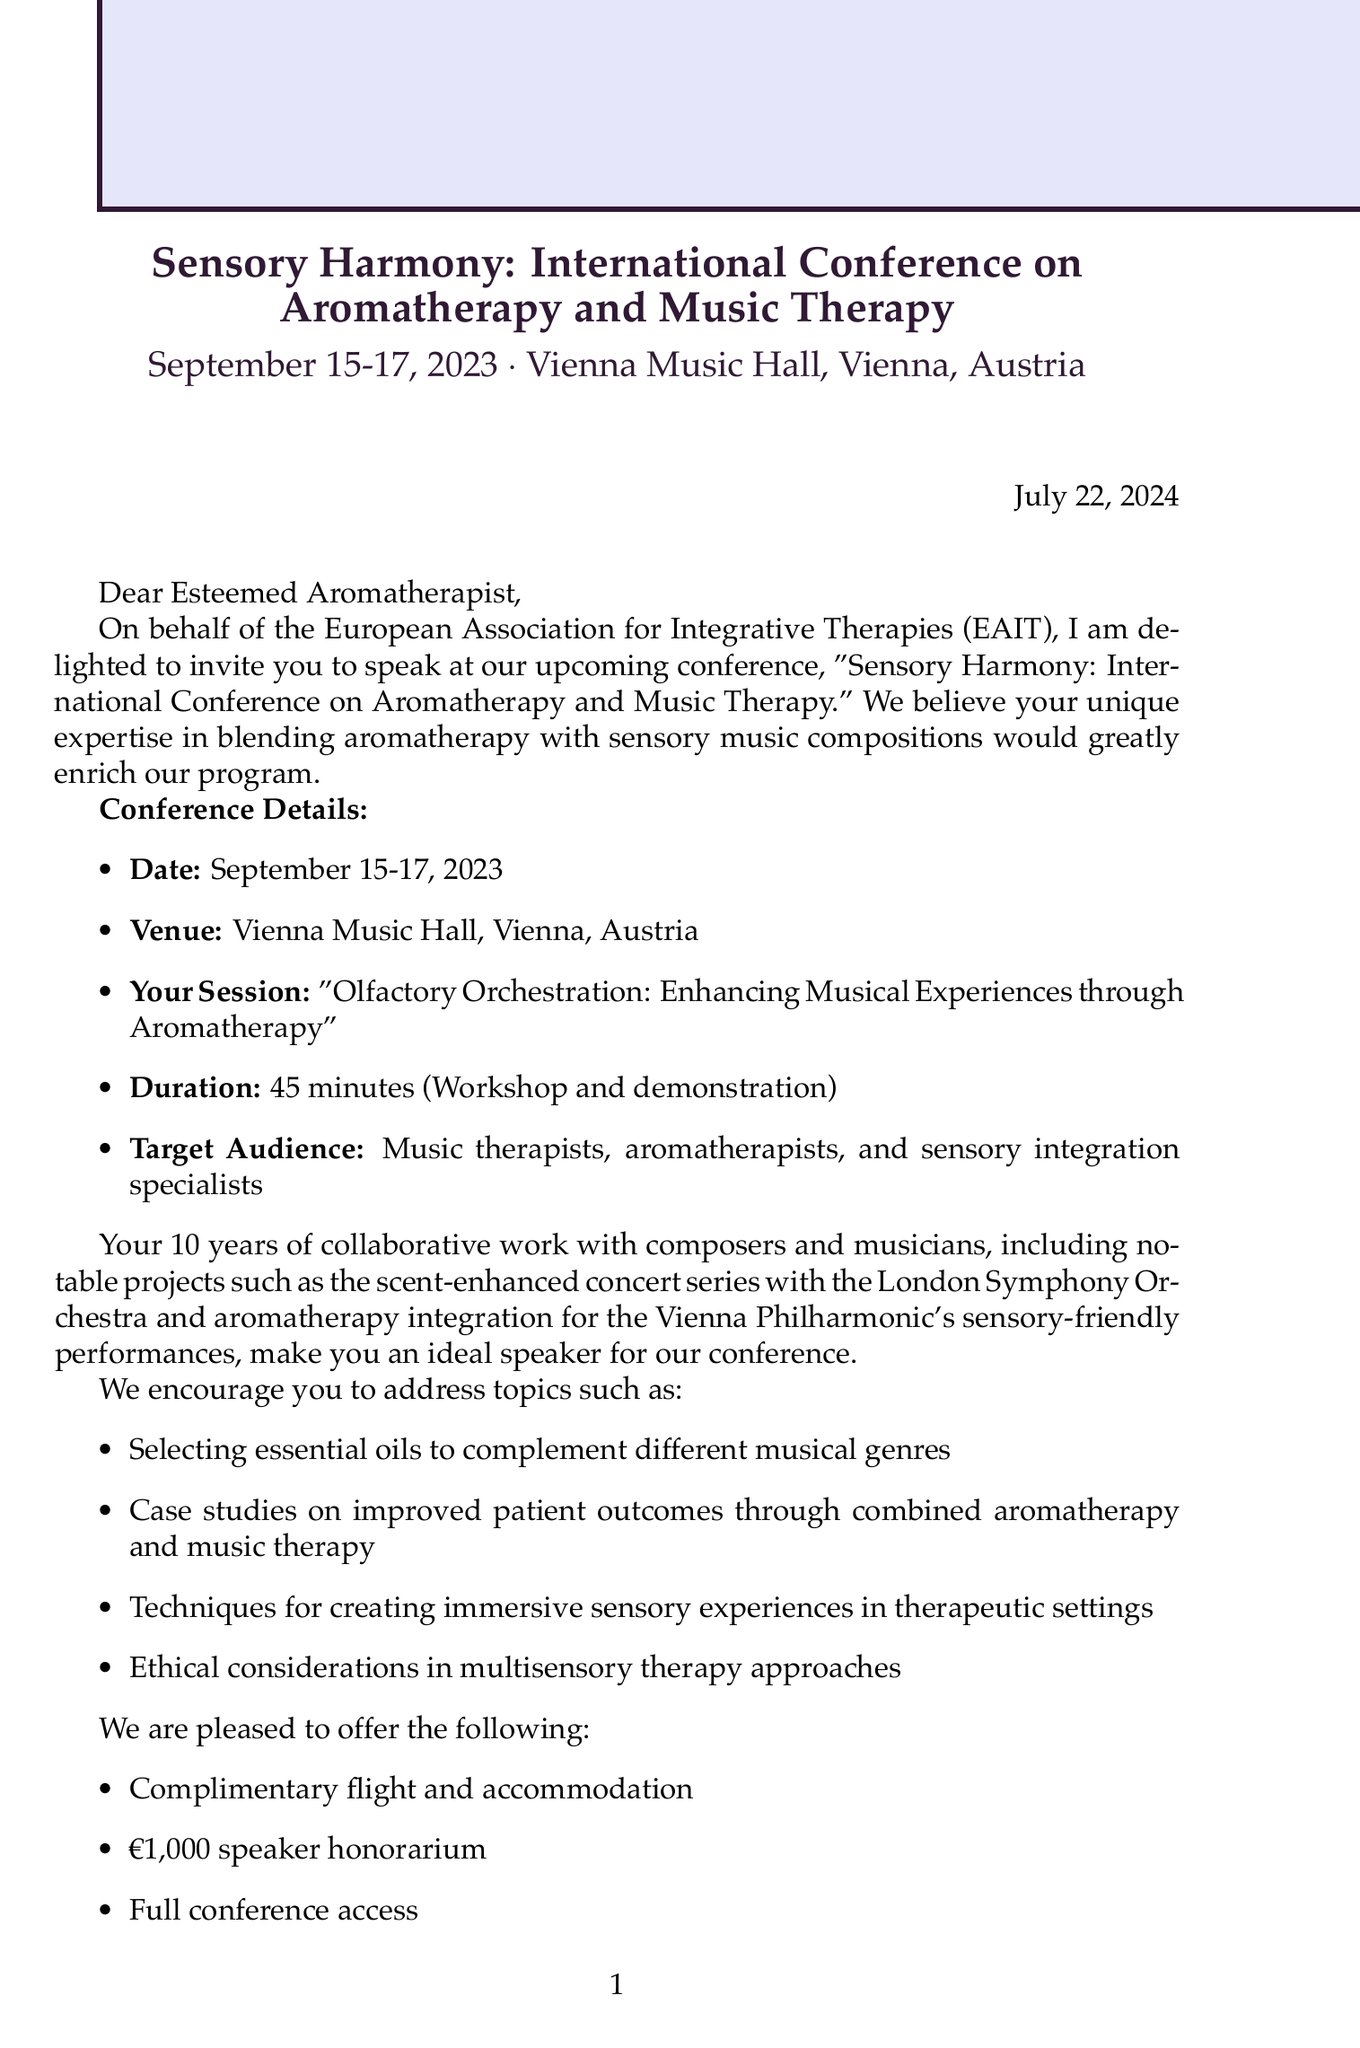What is the name of the conference? The name of the conference is stated at the beginning of the document.
Answer: Sensory Harmony: International Conference on Aromatherapy and Music Therapy What are the conference dates? The conference dates are mentioned in the conference details section.
Answer: September 15-17, 2023 Where is the conference being held? The location of the conference is provided in the conference details.
Answer: Vienna Music Hall, Vienna, Austria What is the session title for the invited speaker? The session title is listed under the invitation specifics section.
Answer: Olfactory Orchestration: Enhancing Musical Experiences through Aromatherapy How long is the speaker's session duration? The session duration is mentioned clearly in the invitation specifics.
Answer: 45 minutes What is the speaker honorarium? The compensation for speaking is outlined in the logistical information section.
Answer: €1,000 Who is the contact person for the conference? The contact person is introduced towards the end of the document.
Answer: Dr. Elisa Schubert What is one topic suggested for the speaker to address? Suggested topics are listed under potential topics to address.
Answer: Selecting essential oils to complement different musical genres What is one notable project mentioned related to the speaker? Notable projects are shared in the speaker qualifications section.
Answer: Scent-enhanced concert series with the London Symphony Orchestra By when should the speaker confirm their participation? The deadline for confirmation is indicated at the end of the letter.
Answer: June 30, 2023 